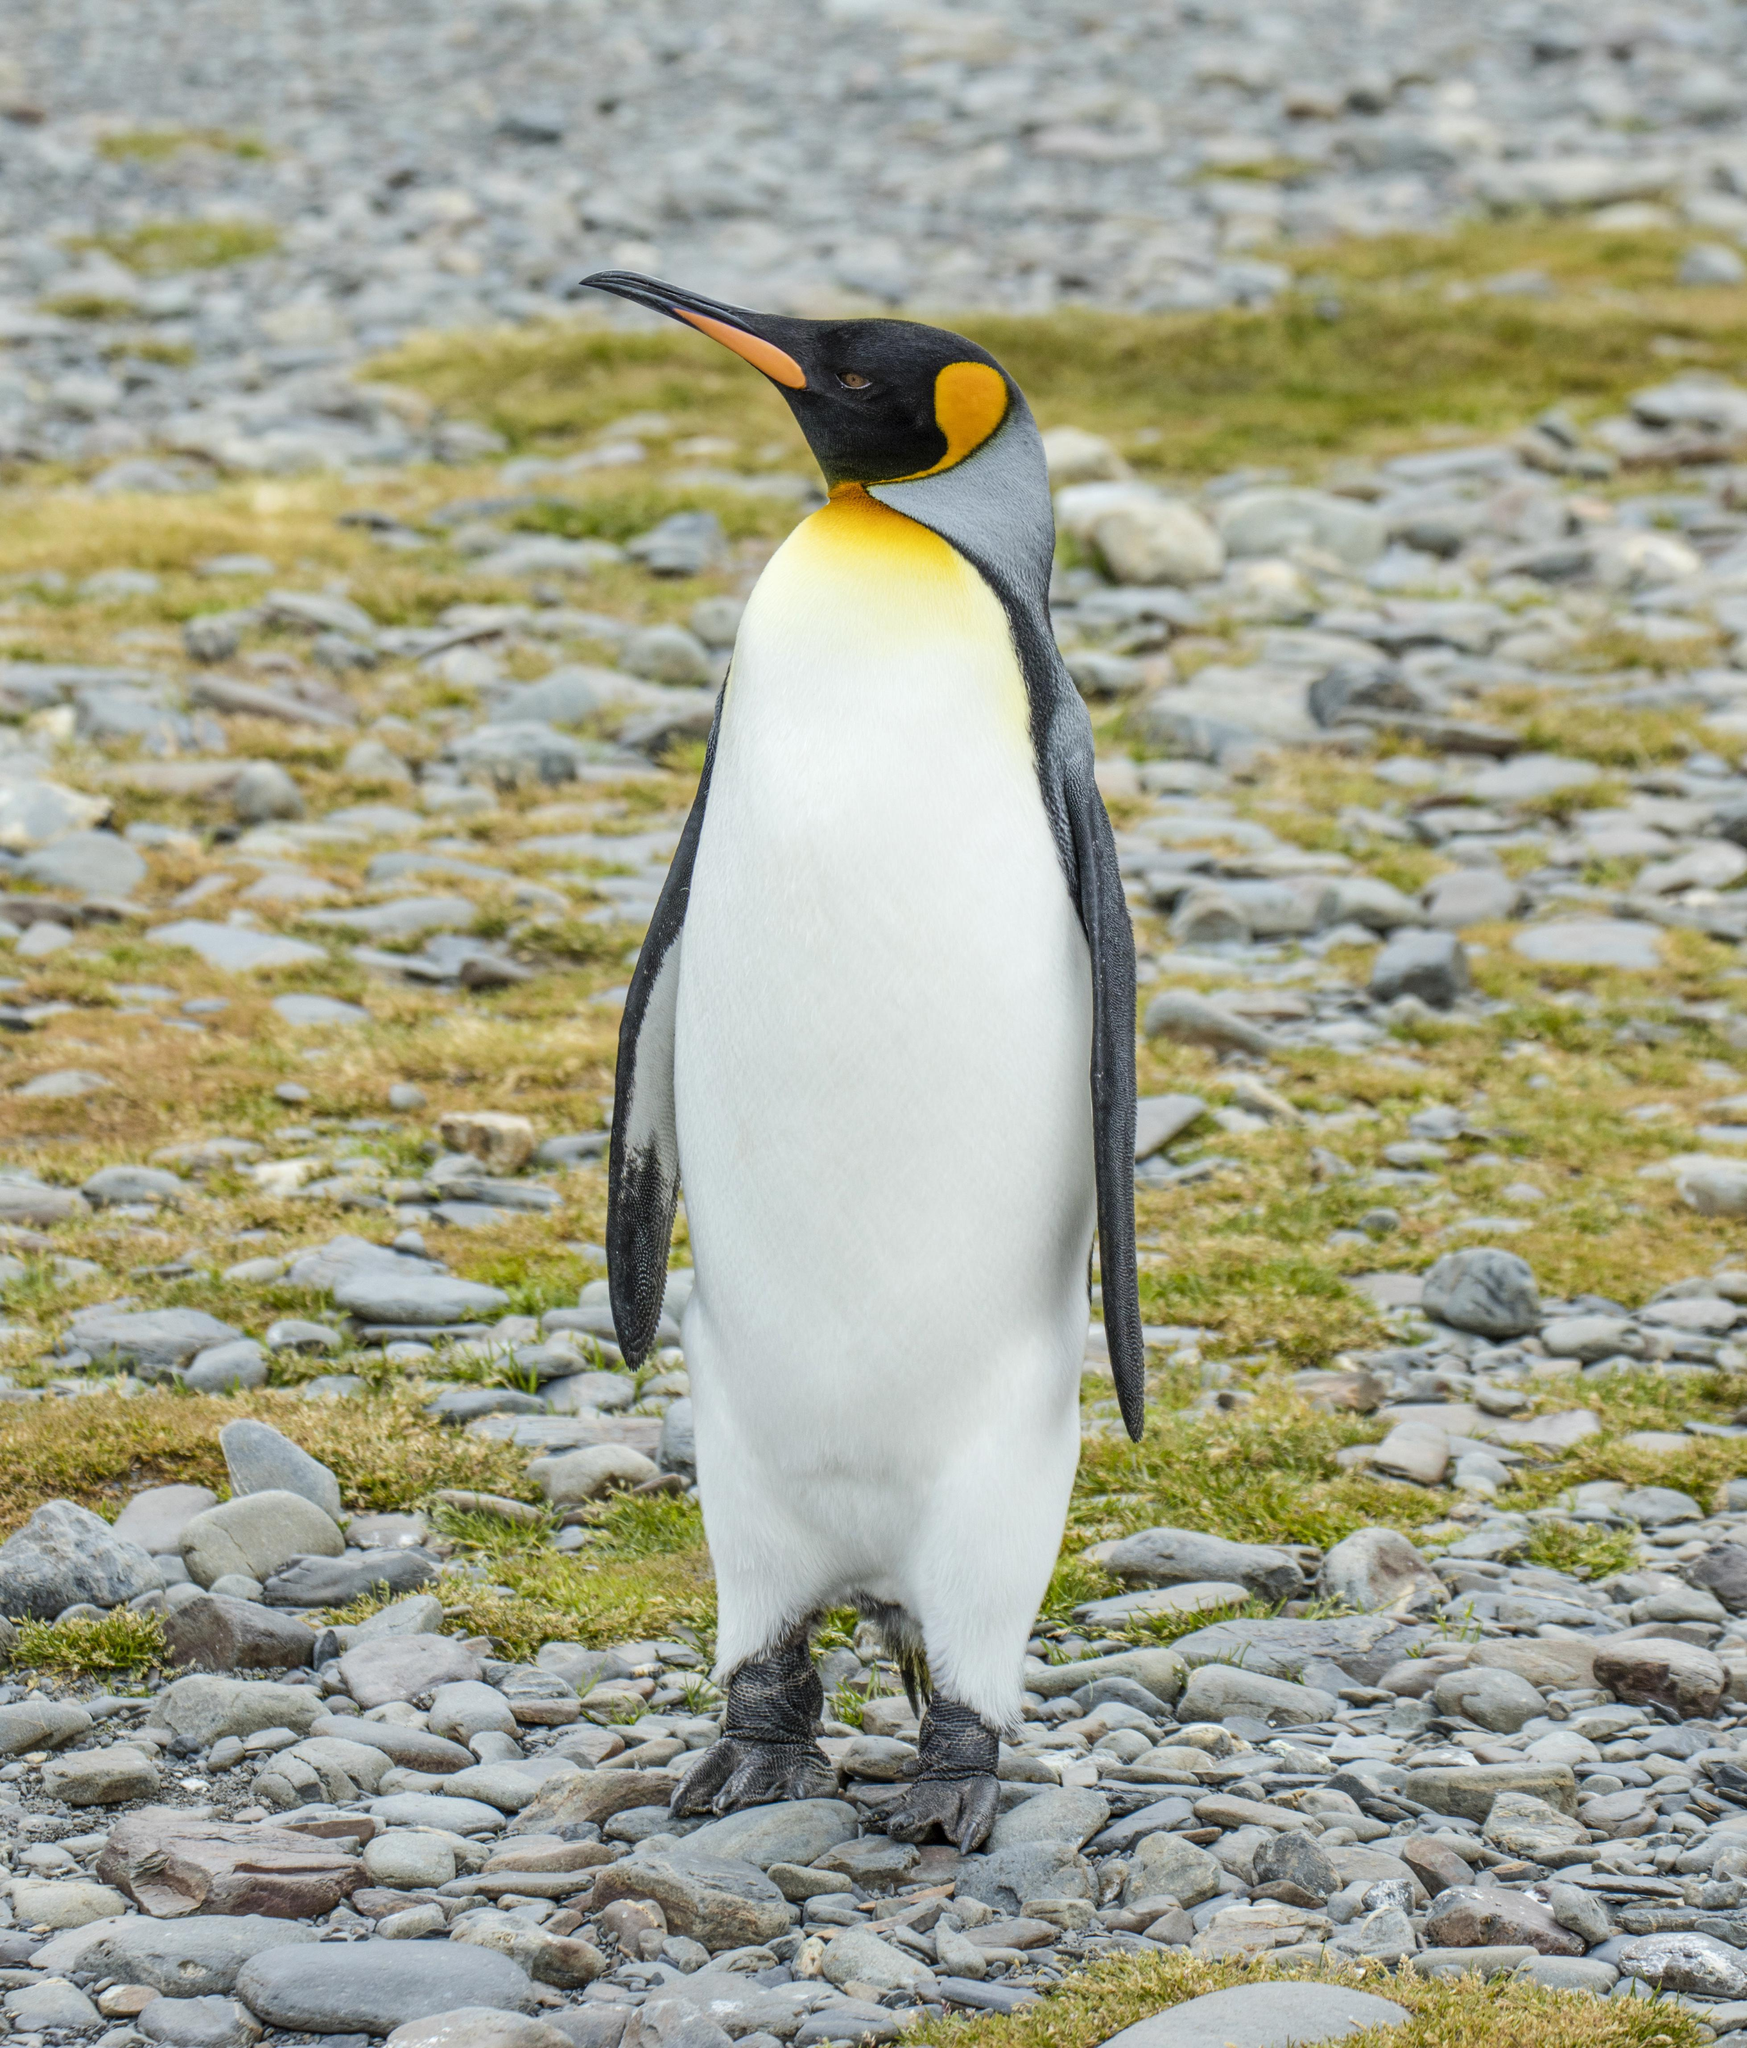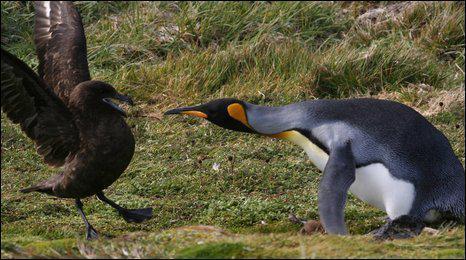The first image is the image on the left, the second image is the image on the right. For the images shown, is this caption "An image shows only a moulting penguin with patchy brown feathers." true? Answer yes or no. No. The first image is the image on the left, the second image is the image on the right. Considering the images on both sides, is "Two penguins stand together in the image on the right." valid? Answer yes or no. No. 